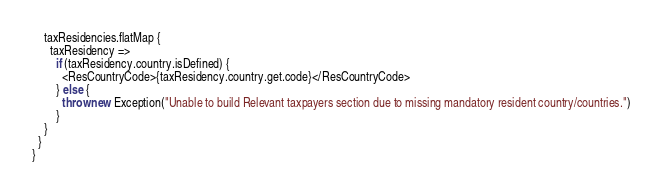Convert code to text. <code><loc_0><loc_0><loc_500><loc_500><_Scala_>    taxResidencies.flatMap {
      taxResidency =>
        if (taxResidency.country.isDefined) {
          <ResCountryCode>{taxResidency.country.get.code}</ResCountryCode>
        } else {
          throw new Exception("Unable to build Relevant taxpayers section due to missing mandatory resident country/countries.")
        }
    }
  }
}
</code> 